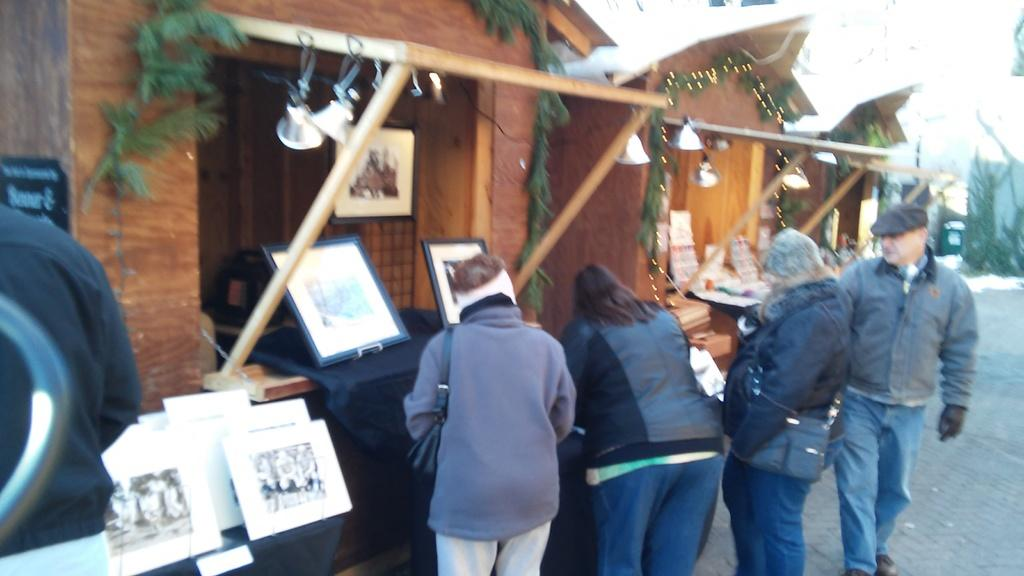How many people are present in the image? There are four people standing on the ground in the image. What can be seen hanging on the walls or displayed in the image? There are photo frames in the image. What type of vegetation is visible in the image? There are plants in the image. What type of lighting is present in the image? Decorative lights are present in the image. What type of structures can be seen in the image? There are sheds in the image. What objects are hanging or attached to the sheds? Bells are visible in the image. Are there any unidentified objects in the image? Yes, there are some unspecified objects in the image. How would you describe the background of the image? The background of the image is blurry. What is the title of the activity taking place in the image? There is no specific activity taking place in the image, so it does not have a title. 